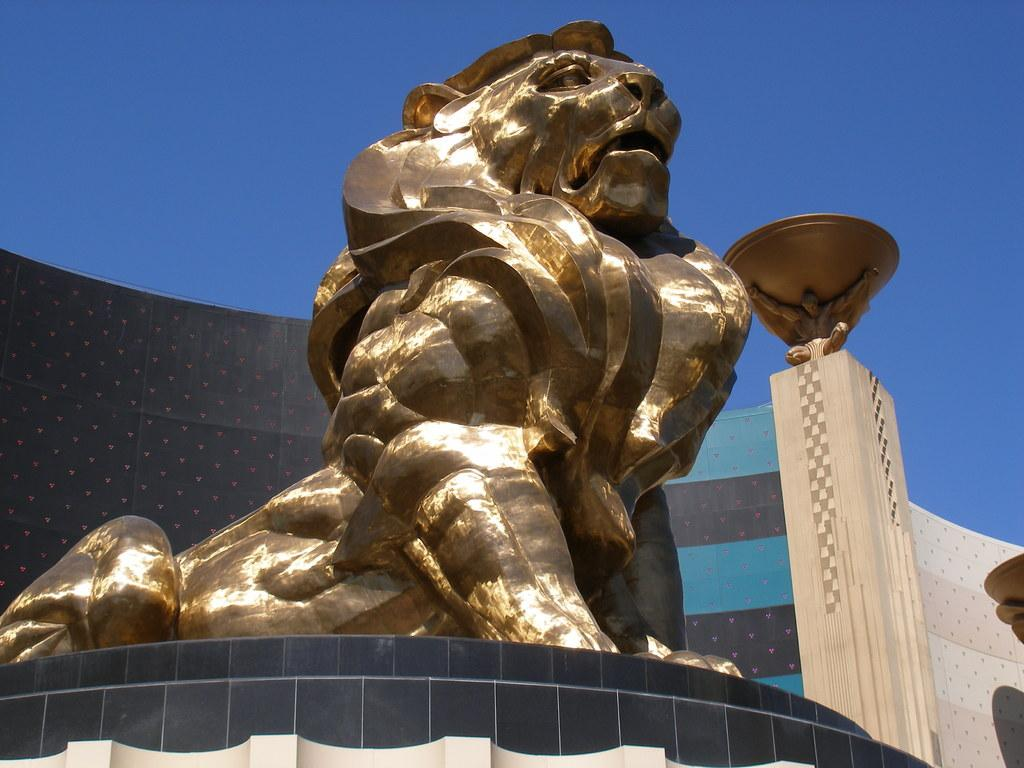What is the main subject in the center of the image? There is a statue in the center of the image. Are there any other statues visible in the image? Yes, there are statues on the right side of the image. What can be seen in the background of the image? There is a wall in the background of the image. What is visible at the top of the image? The sky is visible at the top of the image. Can you tell me what news the person is discussing in the image? There is no person present in the image, so there is no discussion or news to report. 